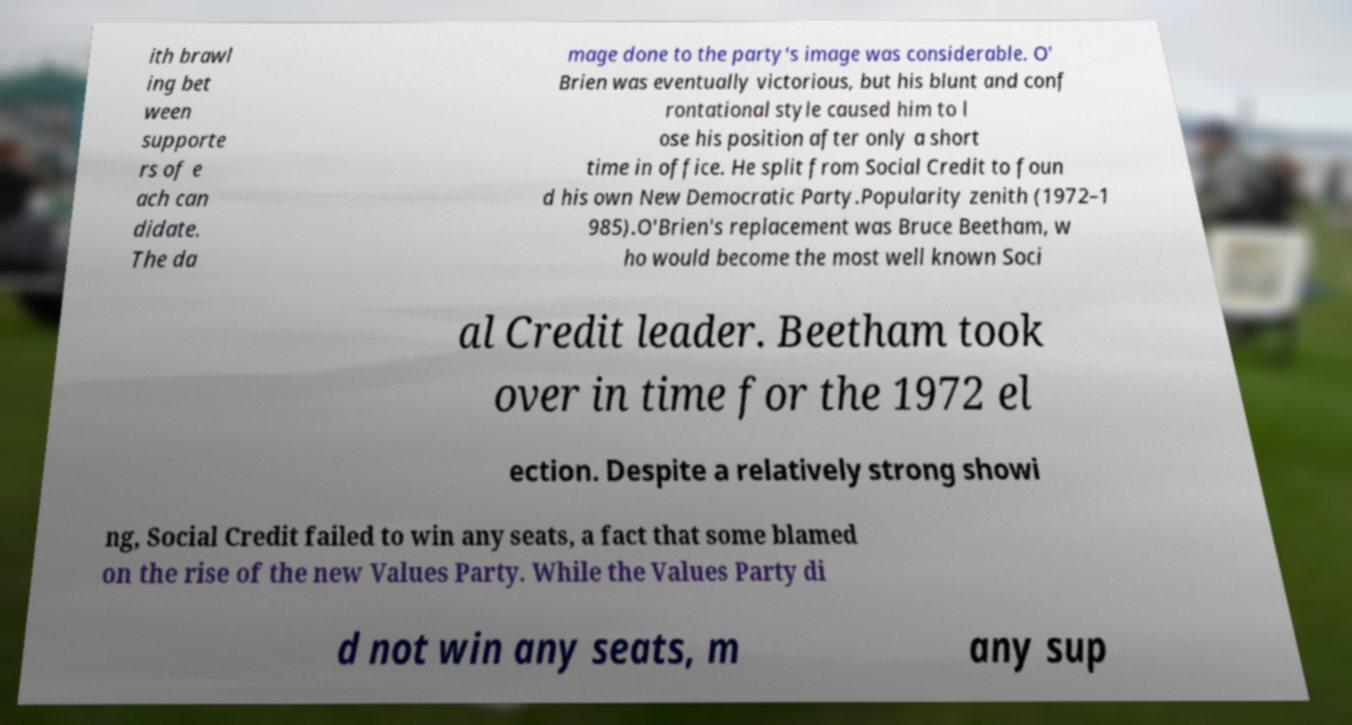Can you read and provide the text displayed in the image?This photo seems to have some interesting text. Can you extract and type it out for me? ith brawl ing bet ween supporte rs of e ach can didate. The da mage done to the party's image was considerable. O' Brien was eventually victorious, but his blunt and conf rontational style caused him to l ose his position after only a short time in office. He split from Social Credit to foun d his own New Democratic Party.Popularity zenith (1972–1 985).O'Brien's replacement was Bruce Beetham, w ho would become the most well known Soci al Credit leader. Beetham took over in time for the 1972 el ection. Despite a relatively strong showi ng, Social Credit failed to win any seats, a fact that some blamed on the rise of the new Values Party. While the Values Party di d not win any seats, m any sup 